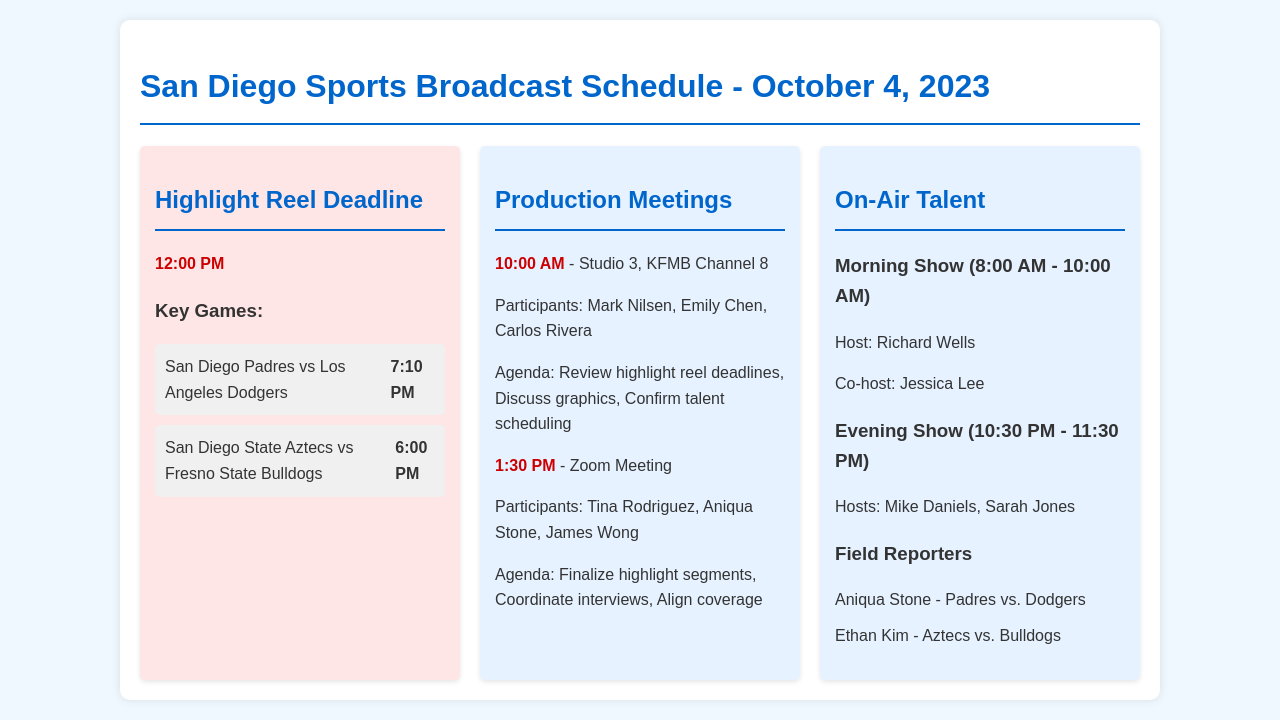What time is the highlight reel deadline? The highlight reel deadline is specified in the document at 12:00 PM.
Answer: 12:00 PM Who are the participants in the morning production meeting? The morning production meeting includes Mark Nilsen, Emily Chen, and Carlos Rivera as participants.
Answer: Mark Nilsen, Emily Chen, Carlos Rivera What game features the San Diego Padres? The San Diego Padres are playing against the Los Angeles Dodgers as per the document.
Answer: Los Angeles Dodgers What is the time slot of the evening show? The time slot of the evening show is mentioned in the document as 10:30 PM - 11:30 PM.
Answer: 10:30 PM - 11:30 PM How many field reporters are listed in the schedule? The document lists a total of two field reporters for the events.
Answer: 2 Which location is specified for the morning production meeting? The morning production meeting is scheduled at Studio 3, KFMB Channel 8 according to the document.
Answer: Studio 3, KFMB Channel 8 What is the agenda of the 1:30 PM Zoom meeting? The agenda of the 1:30 PM Zoom meeting includes finalizing highlight segments, coordinating interviews, and aligning coverage.
Answer: Finalize highlight segments, coordinate interviews, align coverage Who is the host of the morning show? The document specifies Richard Wells as the host of the morning show.
Answer: Richard Wells 